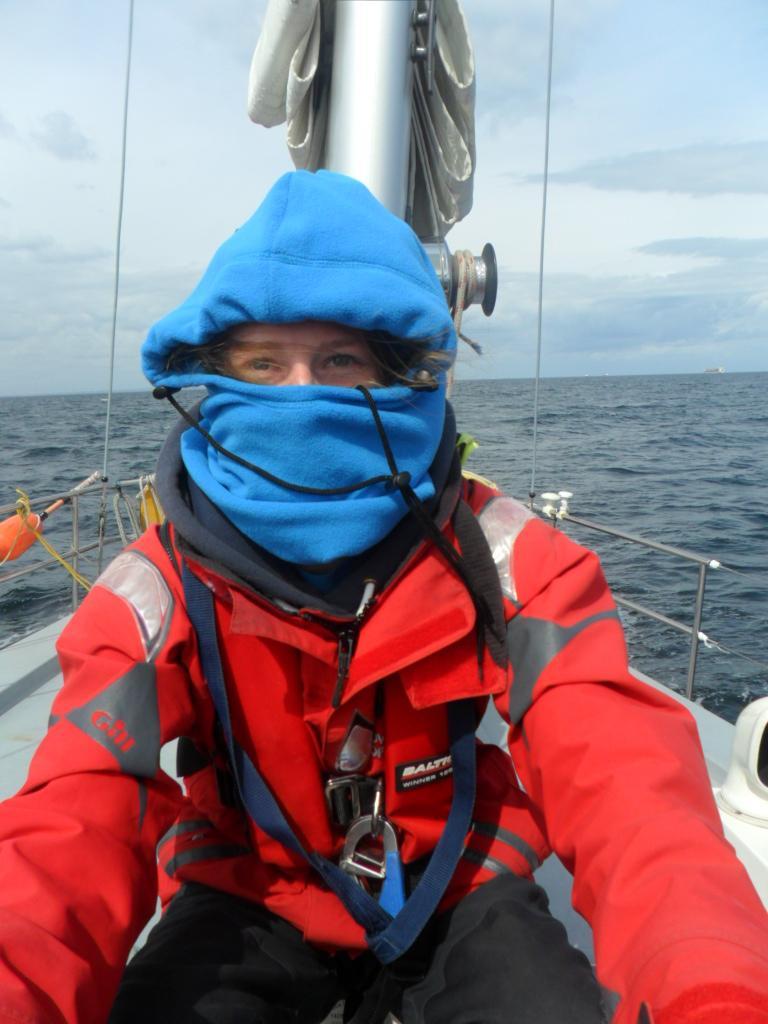Could you give a brief overview of what you see in this image? This picture describe about a women wearing a red color jacket covering her face with blue cloth sitting in the ship. Behind we can see silver pole with curtain. In the background we can see blue sea water. 